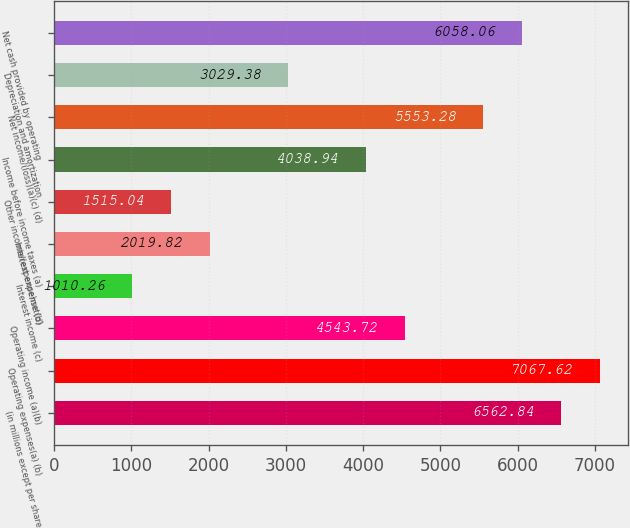Convert chart to OTSL. <chart><loc_0><loc_0><loc_500><loc_500><bar_chart><fcel>(in millions except per share<fcel>Operating expenses(a) (b)<fcel>Operating income (a)(b)<fcel>Interest income (c)<fcel>Interest expense (d)<fcel>Other income/(expense)net(b)<fcel>Income before income taxes (a)<fcel>Net income/(loss)(a)(c) (d)<fcel>Depreciation and amortization<fcel>Net cash provided by operating<nl><fcel>6562.84<fcel>7067.62<fcel>4543.72<fcel>1010.26<fcel>2019.82<fcel>1515.04<fcel>4038.94<fcel>5553.28<fcel>3029.38<fcel>6058.06<nl></chart> 